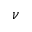<formula> <loc_0><loc_0><loc_500><loc_500>\nu</formula> 